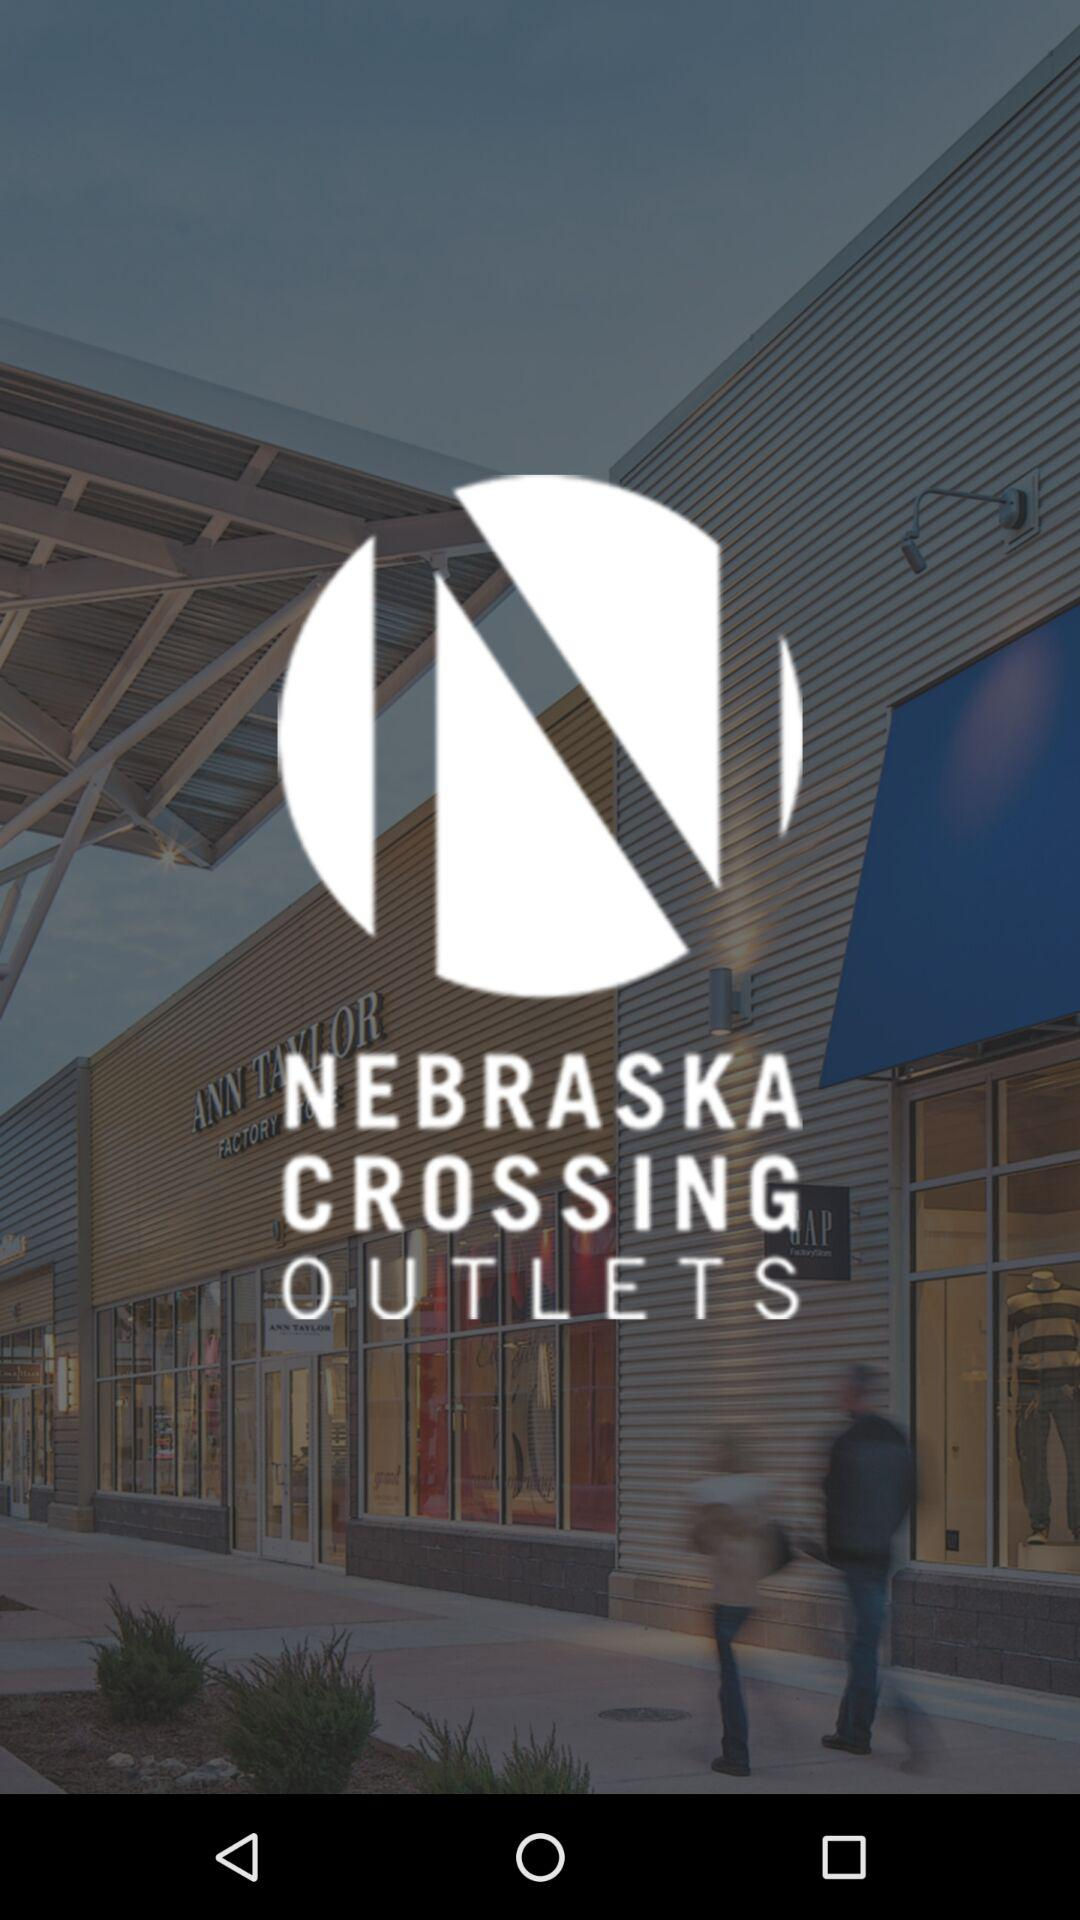What is the application name? The application name is "NEX App". 